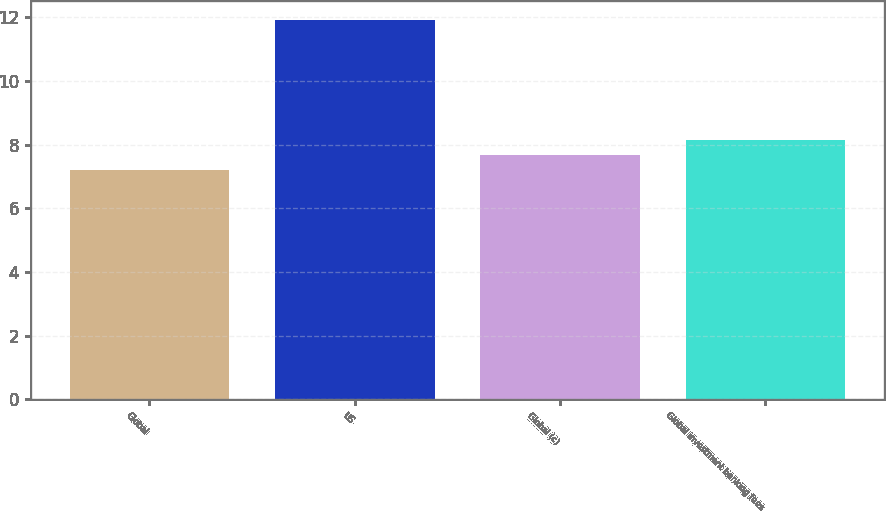Convert chart. <chart><loc_0><loc_0><loc_500><loc_500><bar_chart><fcel>Global<fcel>US<fcel>Global (c)<fcel>Global investment banking fees<nl><fcel>7.2<fcel>11.9<fcel>7.67<fcel>8.14<nl></chart> 